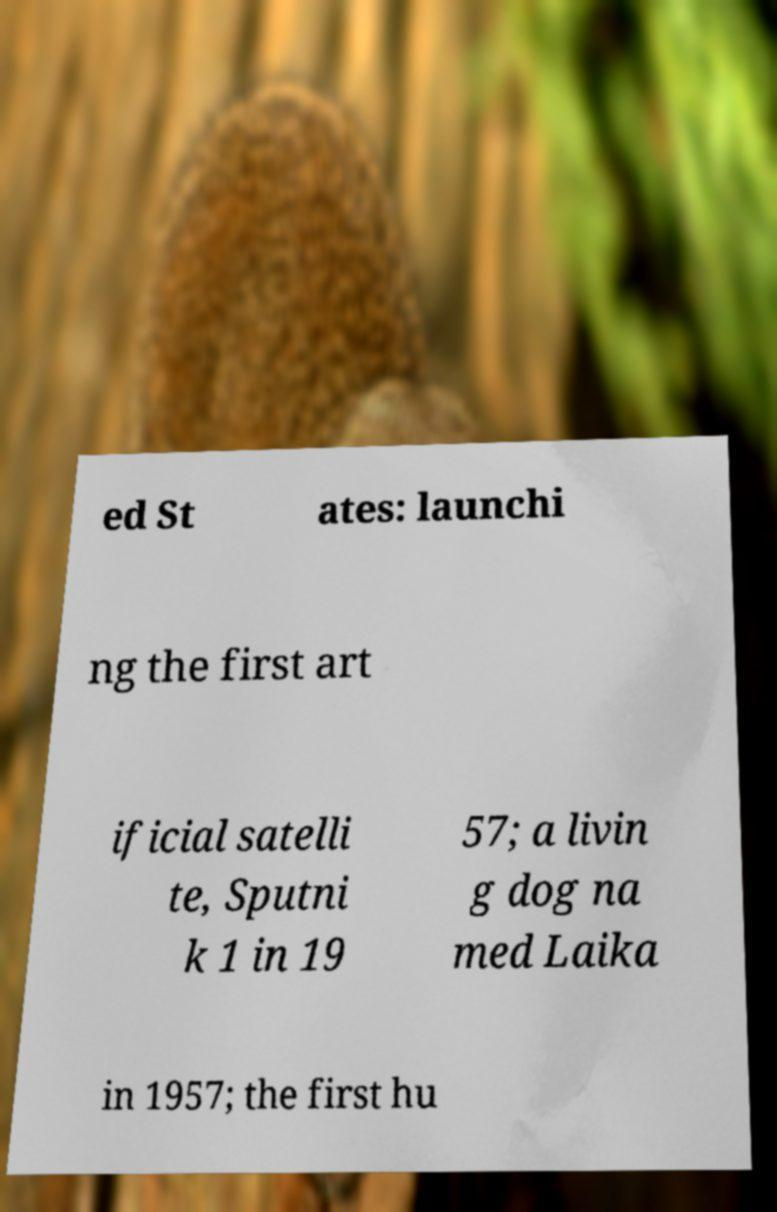Can you accurately transcribe the text from the provided image for me? ed St ates: launchi ng the first art ificial satelli te, Sputni k 1 in 19 57; a livin g dog na med Laika in 1957; the first hu 